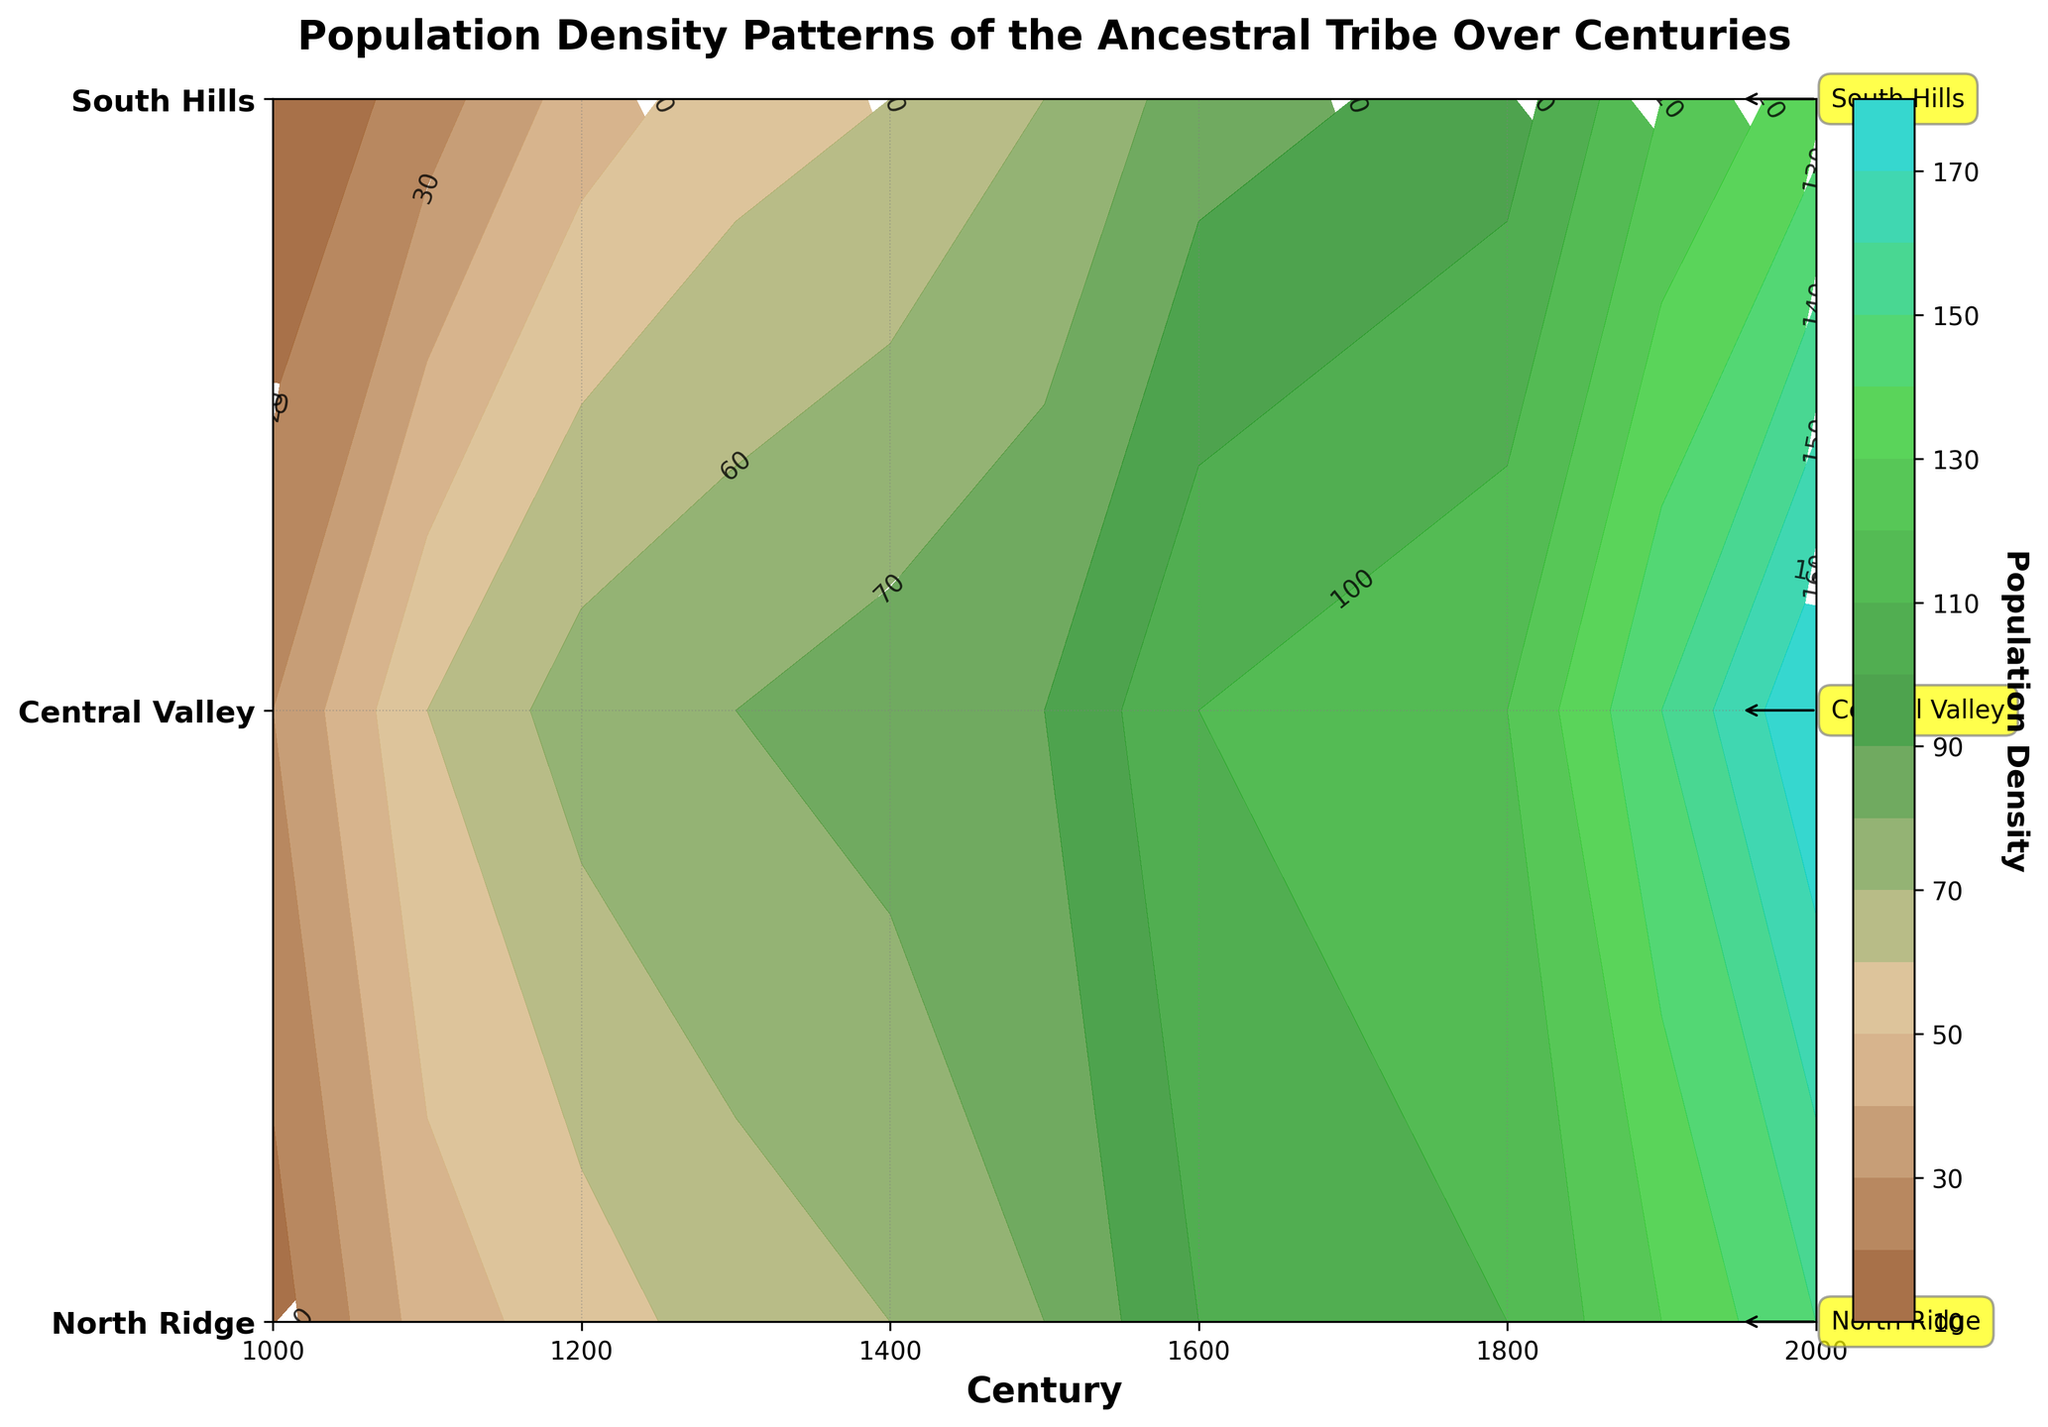What is the title of the contour plot? The title is written at the top of the plot and often provides a description of the data being presented. In this case, the title is "Population Density Patterns of the Ancestral Tribe Over Centuries."
Answer: Population Density Patterns of the Ancestral Tribe Over Centuries Which century shows a population density of 150 in the Central Valley? By examining the contour plot and finding the intersection between the Central Valley region line and the contour line that represents a population density of 150, we see it corresponds to the year 2000.
Answer: 2000 What is the population density in the South Hills region in the year 1400? To find this value, trace the year 1400 down to the South Hills line on the y-axis and read the population density directly from the contour label, which shows 60.
Answer: 60 Compare the population density in North Ridge in the year 1000 to the population density in South Hills in the year 2000. Which is higher and by how much? The population density in North Ridge in the year 1000 is 15, and in South Hills in the year 2000, it is 135. The difference (135 - 15) shows that South Hills in 2000 is higher by 120.
Answer: South Hills in 2000 is higher by 120 Which region had the greatest increase in population density from the year 1000 to the year 2000? By comparing the population densities from the table over the years, we see North Ridge increased from 15 to 150, Central Valley from 30 to 180, and South Hills from 10 to 135. Calculate the differences: North Ridge (150 - 15 = 135), Central Valley (180 - 30 = 150), South Hills (135 - 10 = 125). The Central Valley had the greatest increase (150).
Answer: Central Valley In which century did the population density in North Ridge first surpass 50? Trace the North Ridge line along the y-axis and follow it until it surpasses the 50 mark in the contour plot. This happens in the year 1200.
Answer: 1200 Which region had the highest population density in the year 1800, and what was the density? Locate the year 1800 on the x-axis and follow it through all regions. The Central Valley has the highest population density, which is 120.
Answer: Central Valley, 120 What is the average population density of the Central Valley over all centuries depicted? Retrieve the population densities for the Central Valley from the table: 30, 60, 75, 80, 85, 90, 110, 115, 120, 150, 180. Sum these values: (30 + 60 + 75 + 80 + 85 + 90 + 110 + 115 + 120 + 150 + 180) = 1095. Divide by the number of data points (11): 1095/11 = 99.55.
Answer: 99.55 What was the total population density for all regions combined in the year 1300? Retrieve the population densities for the year 1300 from the table: North Ridge (65), Central Valley (80), South Hills (55). Sum these values: (65 + 80 + 55) = 200.
Answer: 200 Identify a century in which the population density trends for all three regions appear to be relatively close in value. By reviewing the contour plot, the year 1100 shows close population densities: North Ridge (45), Central Valley (60), and South Hills (25) — relatively closer compared to other centuries.
Answer: 1100 